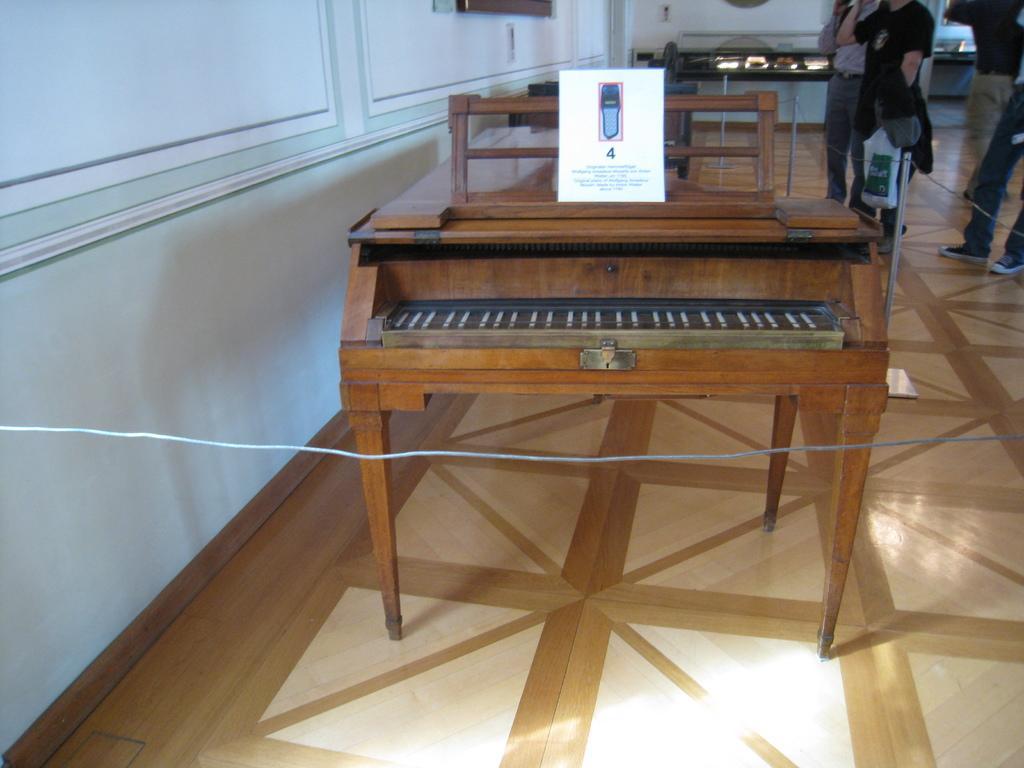Can you describe this image briefly? In this image we can see a piano on which a board is kept. In the background, we can see a few people on the wooden floor., photo frames on the wall and a few things kept here. 